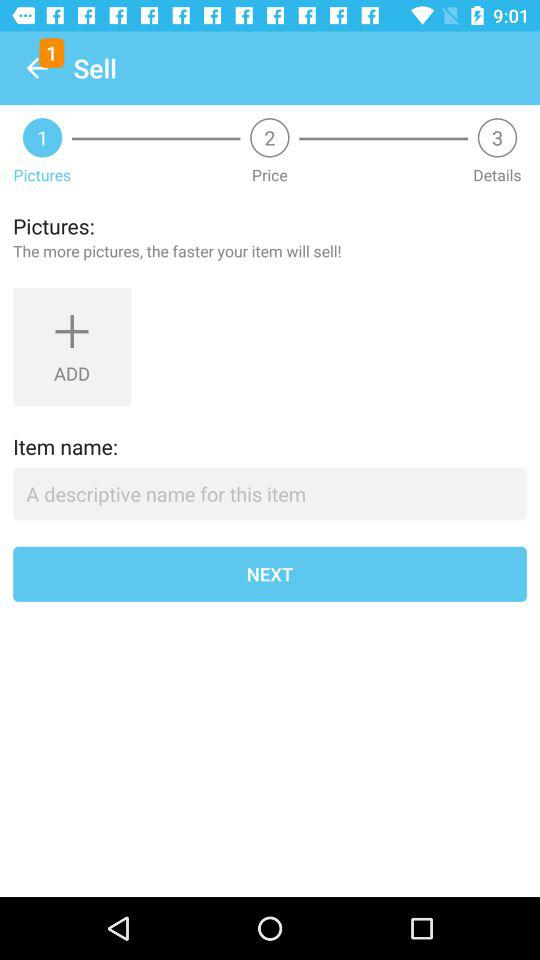Which step is the user currently on? The user is currently on the "Pictures" step. 